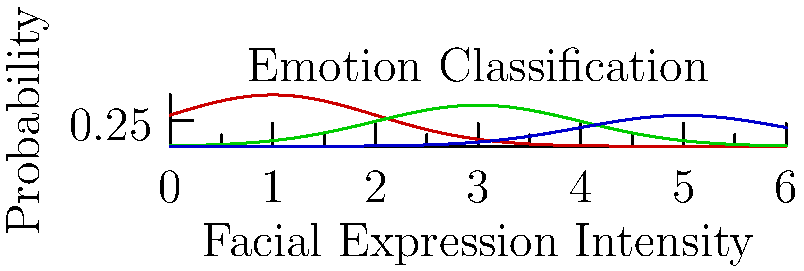In the context of interpreting Nat King Cole's performances, which facial expression intensity range would likely correspond to his rendition of "Smile," considering the song's bittersweet message and the graph provided? To answer this question, we need to follow these steps:

1. Analyze the song "Smile" by Nat King Cole:
   - The song has a bittersweet message, encouraging someone to smile through their pain.
   - It combines elements of both happiness and sadness.

2. Examine the graph:
   - The x-axis represents "Facial Expression Intensity."
   - The y-axis represents "Probability."
   - Three emotions are plotted: Happy (red), Sad (green), and Neutral (blue).

3. Interpret the graph:
   - Happy emotions peak at lower intensity (around 1).
   - Sad emotions peak at medium intensity (around 3).
   - Neutral emotions peak at higher intensity (around 5).

4. Consider the song's emotional context:
   - "Smile" requires a blend of happy and sad emotions.
   - The singer needs to convey both hope and melancholy.

5. Determine the appropriate intensity range:
   - The ideal range would be where both happy and sad emotions have significant probabilities.
   - This occurs in the middle range of the graph, between 2 and 4 on the x-axis.

6. Relate to Nat King Cole's performance style:
   - Known for his warm, emotive performances, Cole would likely use subtle facial expressions.
   - This aligns with the middle range of facial expression intensity.

Given these factors, the most appropriate facial expression intensity range for Nat King Cole's rendition of "Smile" would be between 2 and 4 on the graph's x-axis.
Answer: 2-4 range on facial expression intensity scale 